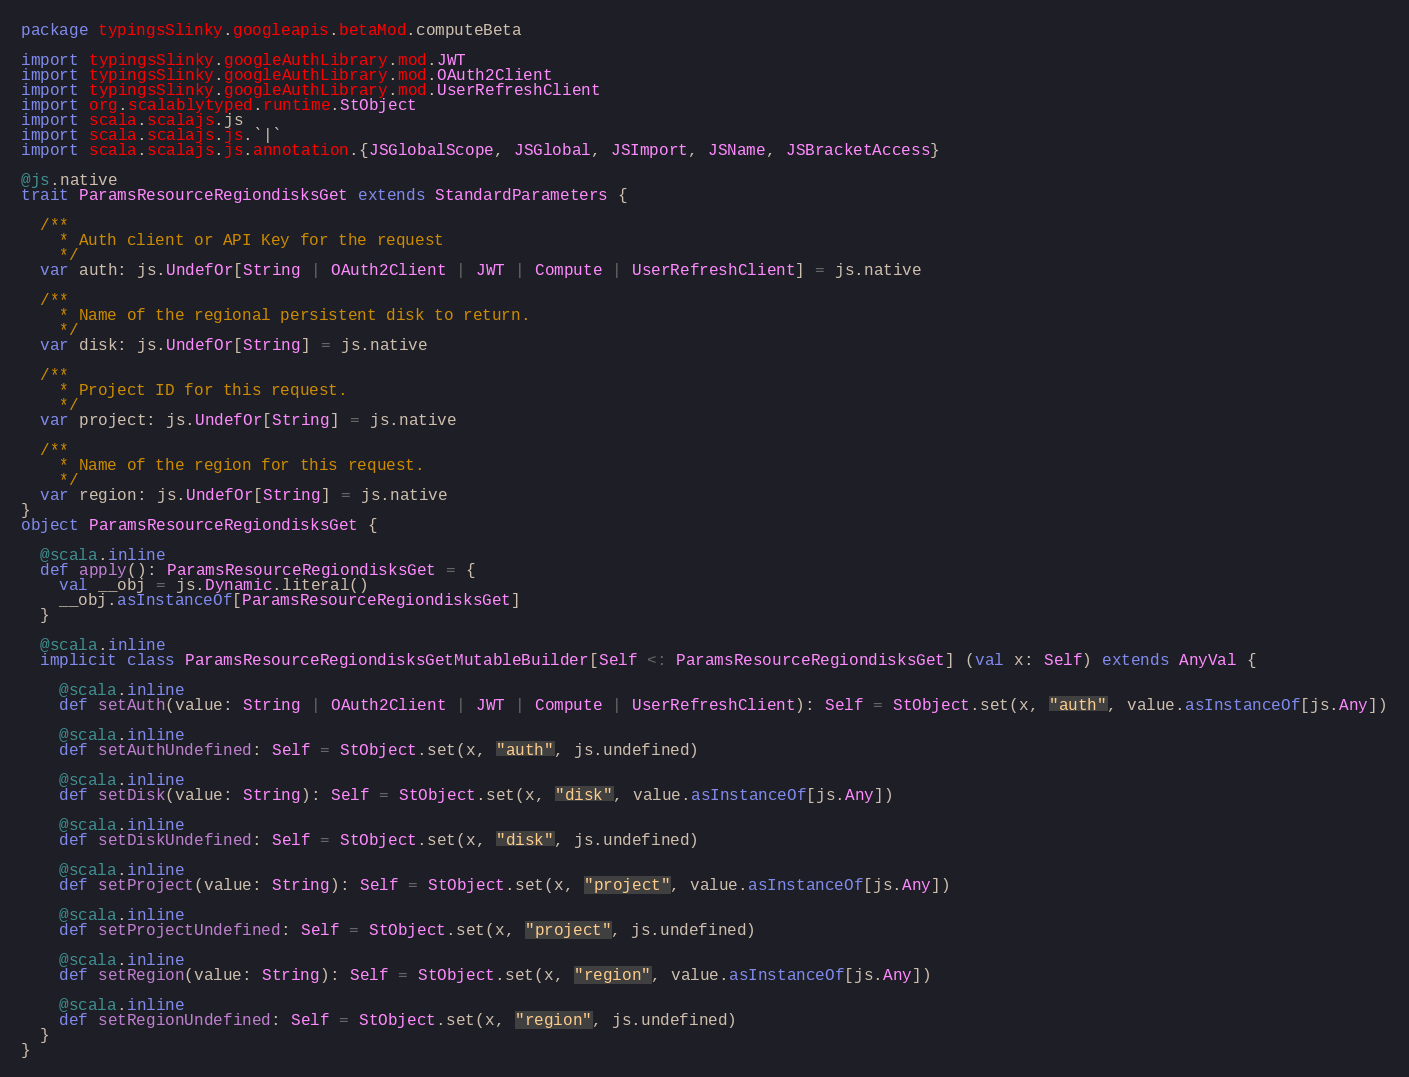Convert code to text. <code><loc_0><loc_0><loc_500><loc_500><_Scala_>package typingsSlinky.googleapis.betaMod.computeBeta

import typingsSlinky.googleAuthLibrary.mod.JWT
import typingsSlinky.googleAuthLibrary.mod.OAuth2Client
import typingsSlinky.googleAuthLibrary.mod.UserRefreshClient
import org.scalablytyped.runtime.StObject
import scala.scalajs.js
import scala.scalajs.js.`|`
import scala.scalajs.js.annotation.{JSGlobalScope, JSGlobal, JSImport, JSName, JSBracketAccess}

@js.native
trait ParamsResourceRegiondisksGet extends StandardParameters {
  
  /**
    * Auth client or API Key for the request
    */
  var auth: js.UndefOr[String | OAuth2Client | JWT | Compute | UserRefreshClient] = js.native
  
  /**
    * Name of the regional persistent disk to return.
    */
  var disk: js.UndefOr[String] = js.native
  
  /**
    * Project ID for this request.
    */
  var project: js.UndefOr[String] = js.native
  
  /**
    * Name of the region for this request.
    */
  var region: js.UndefOr[String] = js.native
}
object ParamsResourceRegiondisksGet {
  
  @scala.inline
  def apply(): ParamsResourceRegiondisksGet = {
    val __obj = js.Dynamic.literal()
    __obj.asInstanceOf[ParamsResourceRegiondisksGet]
  }
  
  @scala.inline
  implicit class ParamsResourceRegiondisksGetMutableBuilder[Self <: ParamsResourceRegiondisksGet] (val x: Self) extends AnyVal {
    
    @scala.inline
    def setAuth(value: String | OAuth2Client | JWT | Compute | UserRefreshClient): Self = StObject.set(x, "auth", value.asInstanceOf[js.Any])
    
    @scala.inline
    def setAuthUndefined: Self = StObject.set(x, "auth", js.undefined)
    
    @scala.inline
    def setDisk(value: String): Self = StObject.set(x, "disk", value.asInstanceOf[js.Any])
    
    @scala.inline
    def setDiskUndefined: Self = StObject.set(x, "disk", js.undefined)
    
    @scala.inline
    def setProject(value: String): Self = StObject.set(x, "project", value.asInstanceOf[js.Any])
    
    @scala.inline
    def setProjectUndefined: Self = StObject.set(x, "project", js.undefined)
    
    @scala.inline
    def setRegion(value: String): Self = StObject.set(x, "region", value.asInstanceOf[js.Any])
    
    @scala.inline
    def setRegionUndefined: Self = StObject.set(x, "region", js.undefined)
  }
}
</code> 